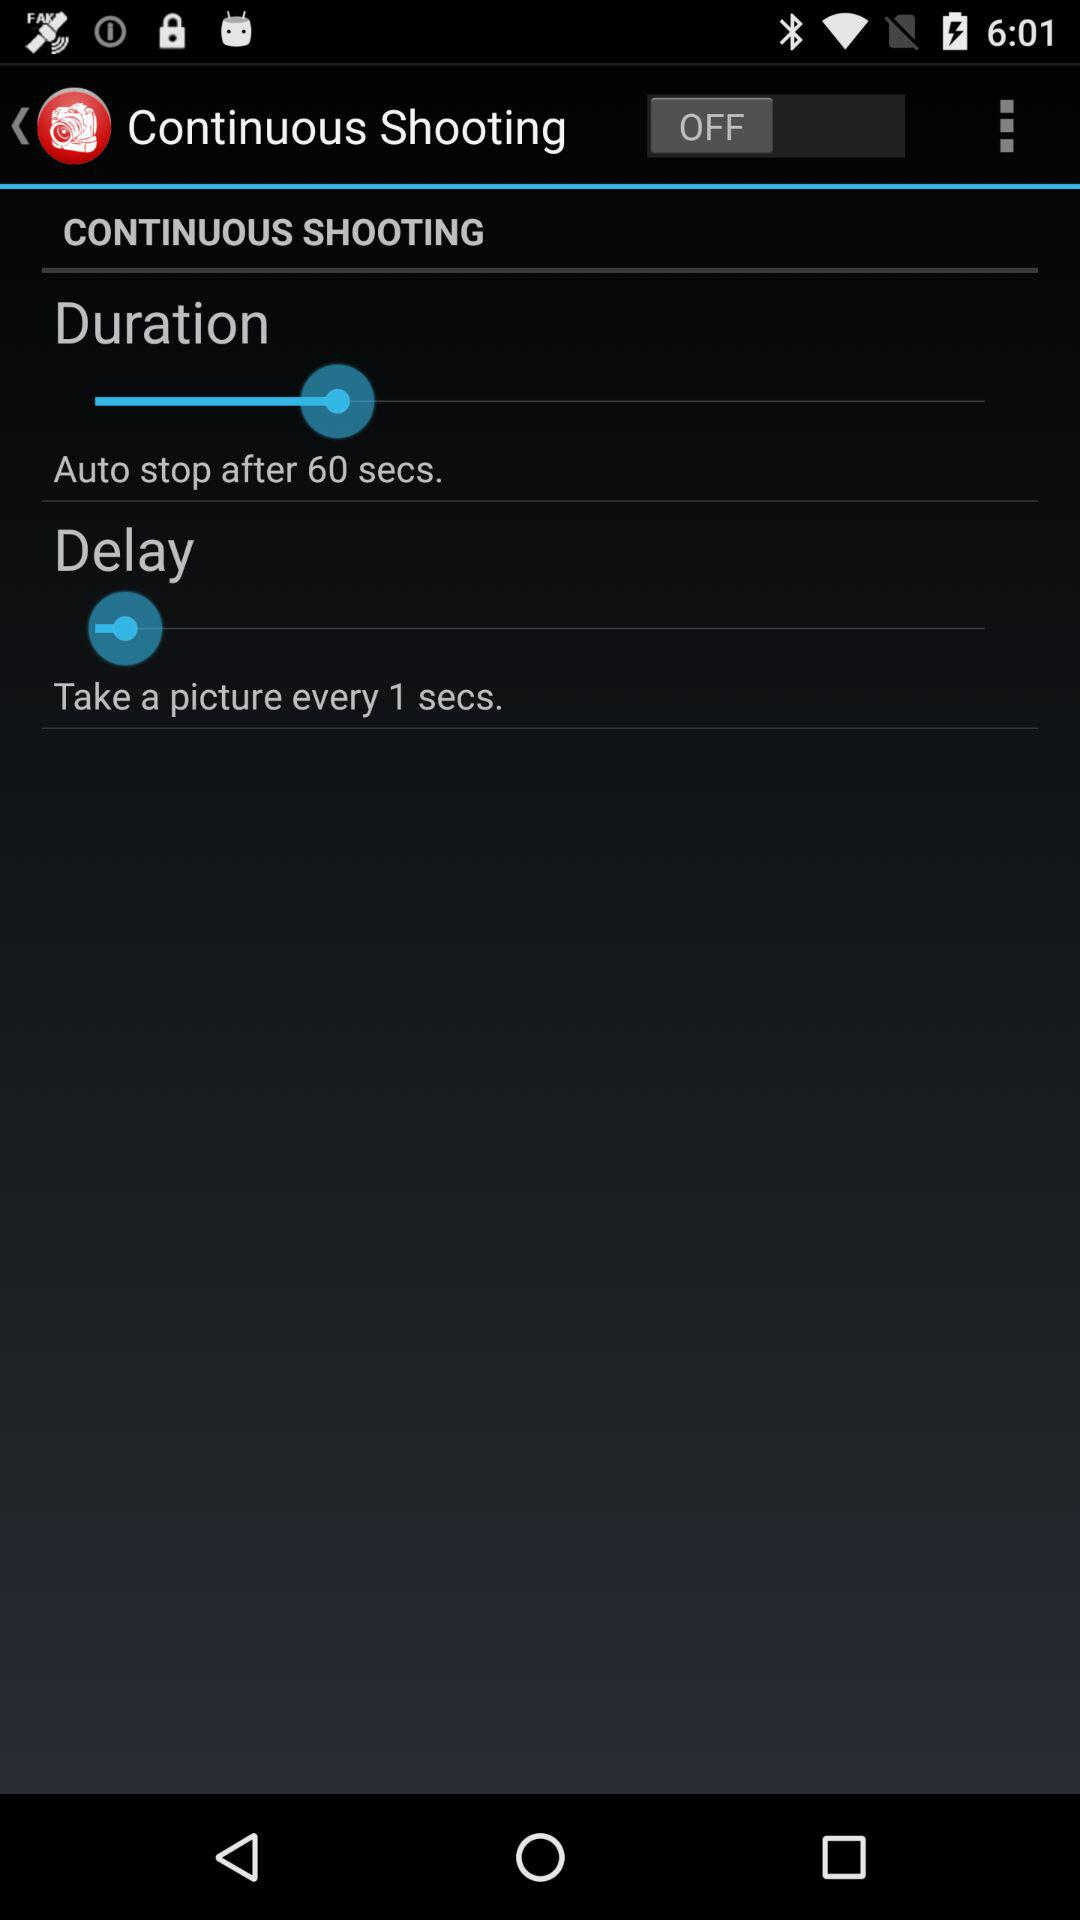What is the status of "Continuous Shooting"? The status is "off". 